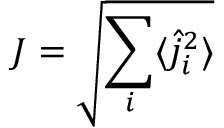<formula> <loc_0><loc_0><loc_500><loc_500>J = \sqrt { \sum _ { i } \langle \hat { j } _ { i } ^ { 2 } \rangle }</formula> 